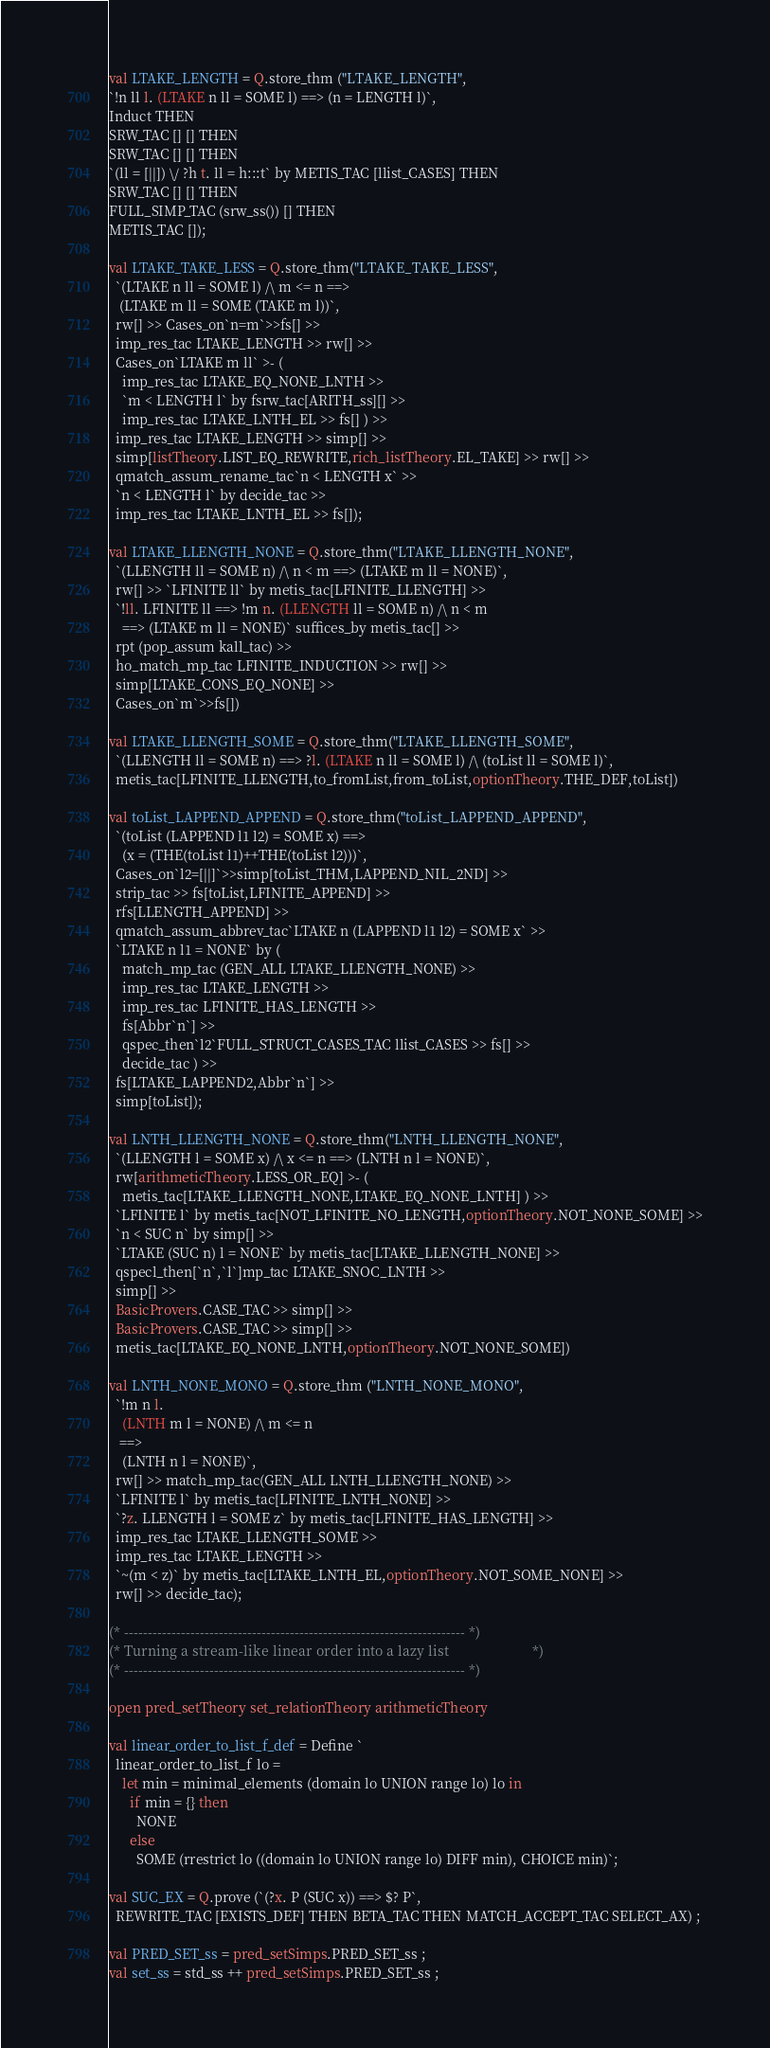<code> <loc_0><loc_0><loc_500><loc_500><_SML_>val LTAKE_LENGTH = Q.store_thm ("LTAKE_LENGTH",
`!n ll l. (LTAKE n ll = SOME l) ==> (n = LENGTH l)`,
Induct THEN
SRW_TAC [] [] THEN
SRW_TAC [] [] THEN
`(ll = [||]) \/ ?h t. ll = h:::t` by METIS_TAC [llist_CASES] THEN
SRW_TAC [] [] THEN
FULL_SIMP_TAC (srw_ss()) [] THEN
METIS_TAC []);

val LTAKE_TAKE_LESS = Q.store_thm("LTAKE_TAKE_LESS",
  `(LTAKE n ll = SOME l) /\ m <= n ==>
   (LTAKE m ll = SOME (TAKE m l))`,
  rw[] >> Cases_on`n=m`>>fs[] >>
  imp_res_tac LTAKE_LENGTH >> rw[] >>
  Cases_on`LTAKE m ll` >- (
    imp_res_tac LTAKE_EQ_NONE_LNTH >>
    `m < LENGTH l` by fsrw_tac[ARITH_ss][] >>
    imp_res_tac LTAKE_LNTH_EL >> fs[] ) >>
  imp_res_tac LTAKE_LENGTH >> simp[] >>
  simp[listTheory.LIST_EQ_REWRITE,rich_listTheory.EL_TAKE] >> rw[] >>
  qmatch_assum_rename_tac`n < LENGTH x` >>
  `n < LENGTH l` by decide_tac >>
  imp_res_tac LTAKE_LNTH_EL >> fs[]);

val LTAKE_LLENGTH_NONE = Q.store_thm("LTAKE_LLENGTH_NONE",
  `(LLENGTH ll = SOME n) /\ n < m ==> (LTAKE m ll = NONE)`,
  rw[] >> `LFINITE ll` by metis_tac[LFINITE_LLENGTH] >>
  `!ll. LFINITE ll ==> !m n. (LLENGTH ll = SOME n) /\ n < m
    ==> (LTAKE m ll = NONE)` suffices_by metis_tac[] >>
  rpt (pop_assum kall_tac) >>
  ho_match_mp_tac LFINITE_INDUCTION >> rw[] >>
  simp[LTAKE_CONS_EQ_NONE] >>
  Cases_on`m`>>fs[])

val LTAKE_LLENGTH_SOME = Q.store_thm("LTAKE_LLENGTH_SOME",
  `(LLENGTH ll = SOME n) ==> ?l. (LTAKE n ll = SOME l) /\ (toList ll = SOME l)`,
  metis_tac[LFINITE_LLENGTH,to_fromList,from_toList,optionTheory.THE_DEF,toList])

val toList_LAPPEND_APPEND = Q.store_thm("toList_LAPPEND_APPEND",
  `(toList (LAPPEND l1 l2) = SOME x) ==>
    (x = (THE(toList l1)++THE(toList l2)))`,
  Cases_on`l2=[||]`>>simp[toList_THM,LAPPEND_NIL_2ND] >>
  strip_tac >> fs[toList,LFINITE_APPEND] >>
  rfs[LLENGTH_APPEND] >>
  qmatch_assum_abbrev_tac`LTAKE n (LAPPEND l1 l2) = SOME x` >>
  `LTAKE n l1 = NONE` by (
    match_mp_tac (GEN_ALL LTAKE_LLENGTH_NONE) >>
    imp_res_tac LTAKE_LENGTH >>
    imp_res_tac LFINITE_HAS_LENGTH >>
    fs[Abbr`n`] >>
    qspec_then`l2`FULL_STRUCT_CASES_TAC llist_CASES >> fs[] >>
    decide_tac ) >>
  fs[LTAKE_LAPPEND2,Abbr`n`] >>
  simp[toList]);

val LNTH_LLENGTH_NONE = Q.store_thm("LNTH_LLENGTH_NONE",
  `(LLENGTH l = SOME x) /\ x <= n ==> (LNTH n l = NONE)`,
  rw[arithmeticTheory.LESS_OR_EQ] >- (
    metis_tac[LTAKE_LLENGTH_NONE,LTAKE_EQ_NONE_LNTH] ) >>
  `LFINITE l` by metis_tac[NOT_LFINITE_NO_LENGTH,optionTheory.NOT_NONE_SOME] >>
  `n < SUC n` by simp[] >>
  `LTAKE (SUC n) l = NONE` by metis_tac[LTAKE_LLENGTH_NONE] >>
  qspecl_then[`n`,`l`]mp_tac LTAKE_SNOC_LNTH >>
  simp[] >>
  BasicProvers.CASE_TAC >> simp[] >>
  BasicProvers.CASE_TAC >> simp[] >>
  metis_tac[LTAKE_EQ_NONE_LNTH,optionTheory.NOT_NONE_SOME])

val LNTH_NONE_MONO = Q.store_thm ("LNTH_NONE_MONO",
  `!m n l.
    (LNTH m l = NONE) /\ m <= n
   ==>
    (LNTH n l = NONE)`,
  rw[] >> match_mp_tac(GEN_ALL LNTH_LLENGTH_NONE) >>
  `LFINITE l` by metis_tac[LFINITE_LNTH_NONE] >>
  `?z. LLENGTH l = SOME z` by metis_tac[LFINITE_HAS_LENGTH] >>
  imp_res_tac LTAKE_LLENGTH_SOME >>
  imp_res_tac LTAKE_LENGTH >>
  `~(m < z)` by metis_tac[LTAKE_LNTH_EL,optionTheory.NOT_SOME_NONE] >>
  rw[] >> decide_tac);

(* ------------------------------------------------------------------------ *)
(* Turning a stream-like linear order into a lazy list                      *)
(* ------------------------------------------------------------------------ *)

open pred_setTheory set_relationTheory arithmeticTheory

val linear_order_to_list_f_def = Define `
  linear_order_to_list_f lo =
    let min = minimal_elements (domain lo UNION range lo) lo in
      if min = {} then
        NONE
      else
        SOME (rrestrict lo ((domain lo UNION range lo) DIFF min), CHOICE min)`;

val SUC_EX = Q.prove (`(?x. P (SUC x)) ==> $? P`,
  REWRITE_TAC [EXISTS_DEF] THEN BETA_TAC THEN MATCH_ACCEPT_TAC SELECT_AX) ;

val PRED_SET_ss = pred_setSimps.PRED_SET_ss ;
val set_ss = std_ss ++ pred_setSimps.PRED_SET_ss ;
</code> 